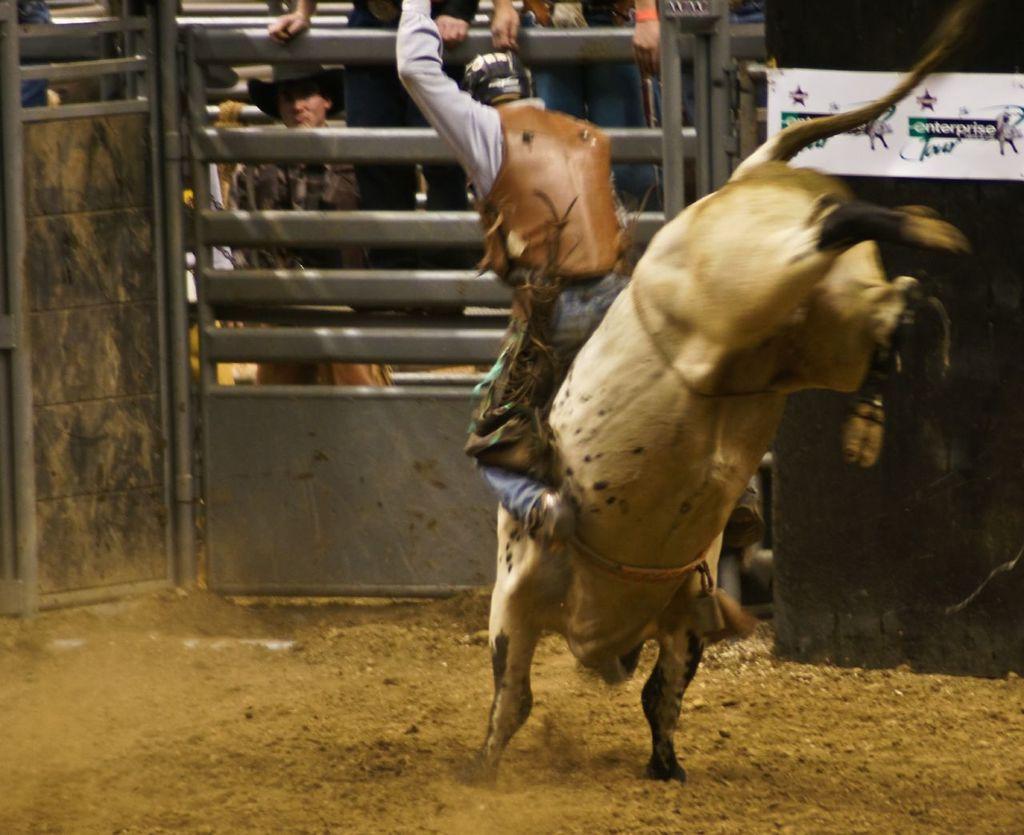Can you describe this image briefly? In this image, we can see a person on the animal and he is wearing a coat and a helmet. In the background, there are gates and we can see a board with some text and logos and there are some people. At the bottom, there is ground. 